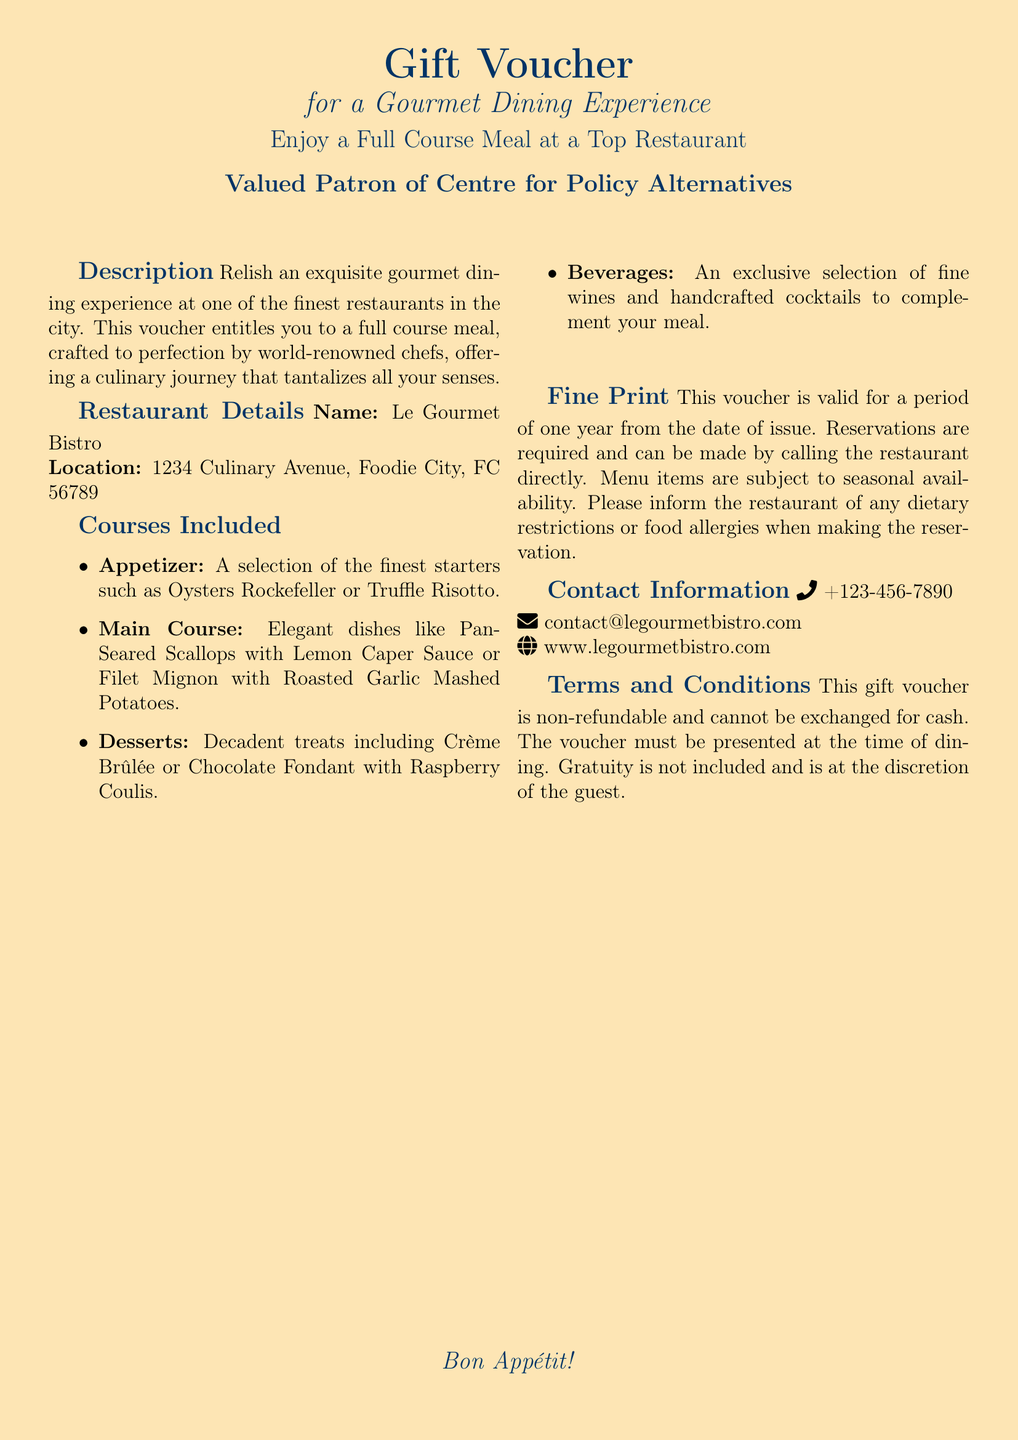What is the name of the restaurant? The name of the restaurant is listed in the restaurant details section of the document.
Answer: Le Gourmet Bistro What is the location of the restaurant? The restaurant's location is specified under the restaurant details section in the document.
Answer: 1234 Culinary Avenue, Foodie City, FC 56789 How long is the voucher valid? The duration of the voucher's validity is mentioned in the fine print section.
Answer: One year What is included in the main course? The dishes included in the main course are listed in the courses included section of the document.
Answer: Pan-Seared Scallops with Lemon Caper Sauce or Filet Mignon with Roasted Garlic Mashed Potatoes What should you inform the restaurant about when making a reservation? The document states that diners should inform the restaurant of specific details related to their dietary needs.
Answer: Dietary restrictions or food allergies Is the voucher refundable? The terms and conditions mention the status of the voucher regarding refunds.
Answer: Non-refundable What kind of desserts are offered? The desserts available are specifically stated in the courses included section.
Answer: Crème Brûlée or Chocolate Fondant with Raspberry Coulis What must be presented at the time of dining? The document specifies the requirement for presenting the voucher at dining time within the terms and conditions.
Answer: The voucher 